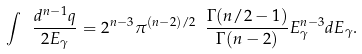<formula> <loc_0><loc_0><loc_500><loc_500>\int \ \frac { d ^ { n - 1 } q } { 2 E _ { \gamma } } = 2 ^ { n - 3 } \pi ^ { ( n - 2 ) / 2 } \ \frac { \Gamma ( n / 2 - 1 ) } { \Gamma ( n - 2 ) } E _ { \gamma } ^ { n - 3 } d E _ { \gamma } .</formula> 